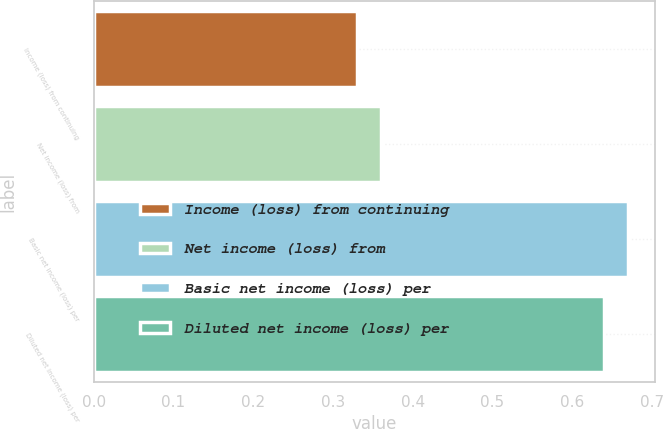Convert chart to OTSL. <chart><loc_0><loc_0><loc_500><loc_500><bar_chart><fcel>Income (loss) from continuing<fcel>Net income (loss) from<fcel>Basic net income (loss) per<fcel>Diluted net income (loss) per<nl><fcel>0.33<fcel>0.36<fcel>0.67<fcel>0.64<nl></chart> 